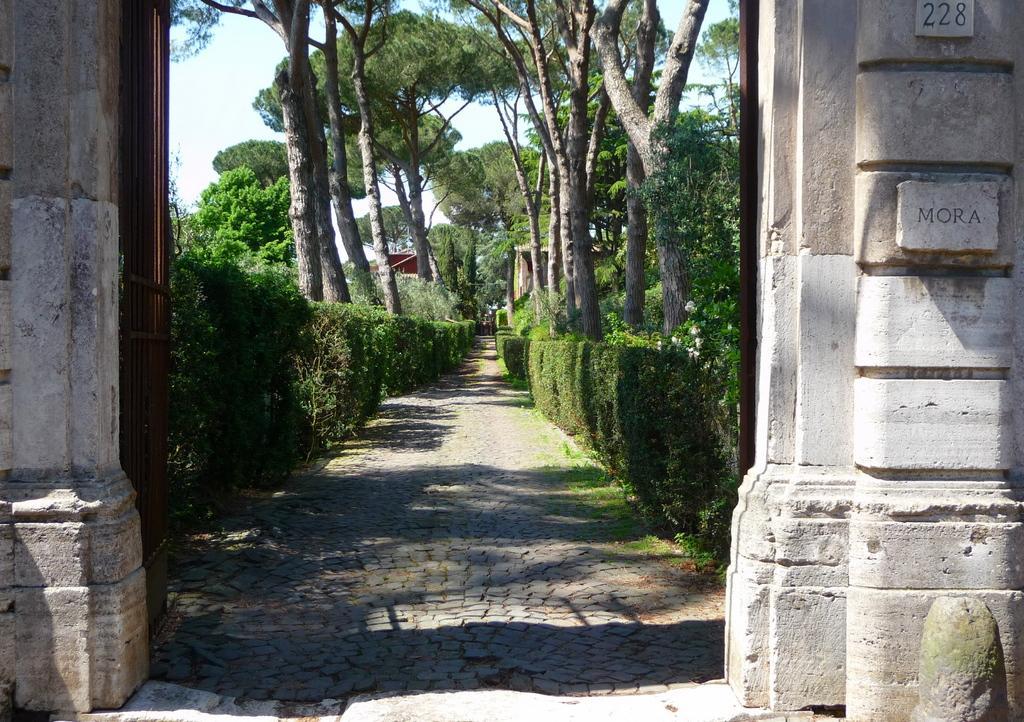In one or two sentences, can you explain what this image depicts? In this image there are trees. In the center there is a path. On the either sides of the path there are hedges. In the foreground there is a wall. There is a gate to the wall. At the top there is the sky. 